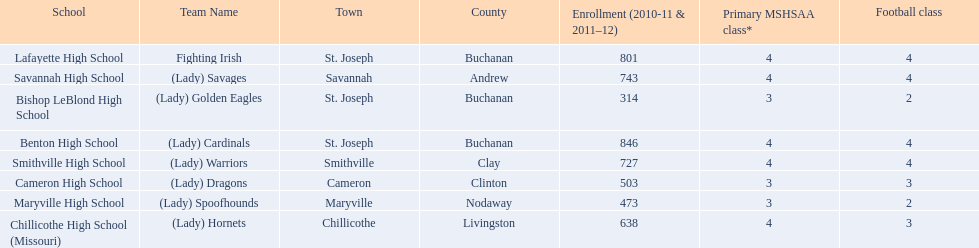What are the names of the schools? Benton High School, Bishop LeBlond High School, Cameron High School, Chillicothe High School (Missouri), Lafayette High School, Maryville High School, Savannah High School, Smithville High School. Of those, which had a total enrollment of less than 500? Bishop LeBlond High School, Maryville High School. And of those, which had the lowest enrollment? Bishop LeBlond High School. 